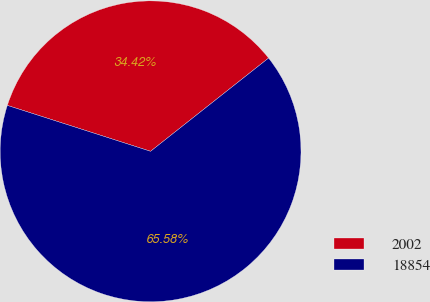Convert chart. <chart><loc_0><loc_0><loc_500><loc_500><pie_chart><fcel>2002<fcel>18854<nl><fcel>34.42%<fcel>65.58%<nl></chart> 